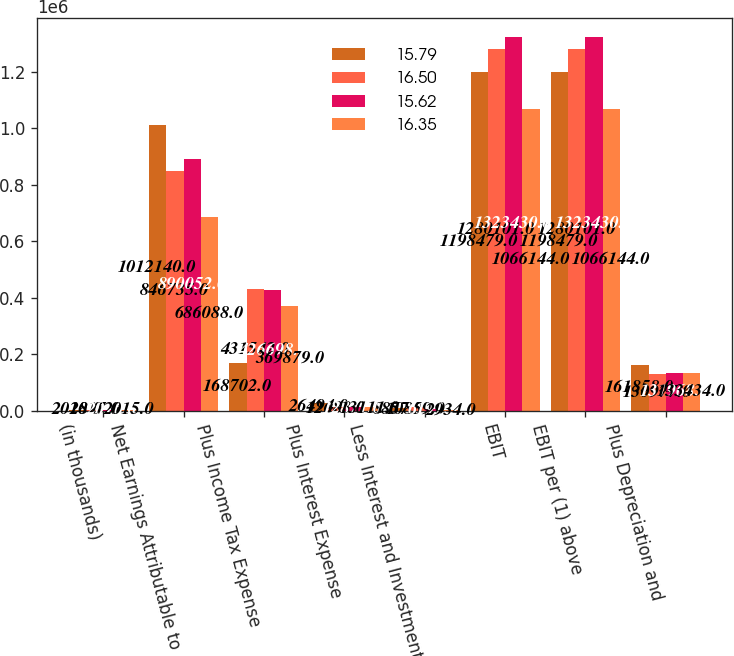Convert chart to OTSL. <chart><loc_0><loc_0><loc_500><loc_500><stacked_bar_chart><ecel><fcel>(in thousands)<fcel>Net Earnings Attributable to<fcel>Plus Income Tax Expense<fcel>Plus Interest Expense<fcel>Less Interest and Investment<fcel>EBIT<fcel>EBIT per (1) above<fcel>Plus Depreciation and<nl><fcel>15.79<fcel>2018<fcel>1.01214e+06<fcel>168702<fcel>26494<fcel>8857<fcel>1.19848e+06<fcel>1.19848e+06<fcel>161858<nl><fcel>16.5<fcel>2017<fcel>846735<fcel>431542<fcel>12683<fcel>10859<fcel>1.2801e+06<fcel>1.2801e+06<fcel>130977<nl><fcel>15.62<fcel>2016<fcel>890052<fcel>426698<fcel>12871<fcel>6191<fcel>1.32343e+06<fcel>1.32343e+06<fcel>131968<nl><fcel>16.35<fcel>2015<fcel>686088<fcel>369879<fcel>13111<fcel>2934<fcel>1.06614e+06<fcel>1.06614e+06<fcel>133434<nl></chart> 